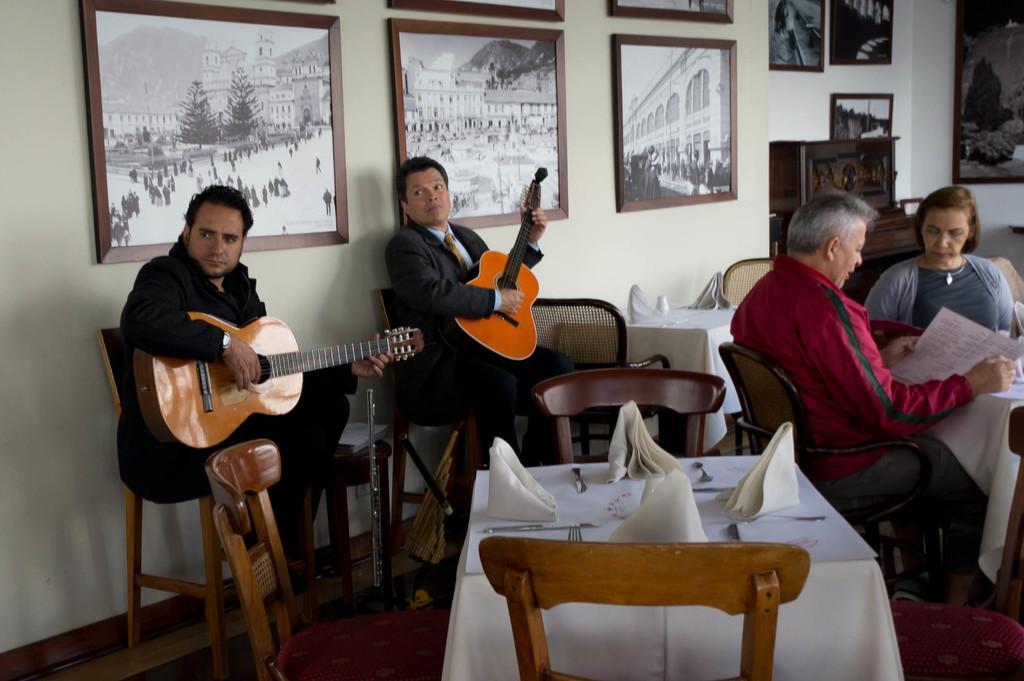Could you give a brief overview of what you see in this image? here in the picture we can see different persons ,two persons are sitting on the chair and holding guitar,two persons on the chair and seeing the menu card which is in front of them on the table,here we can also see different frames on the wall. 